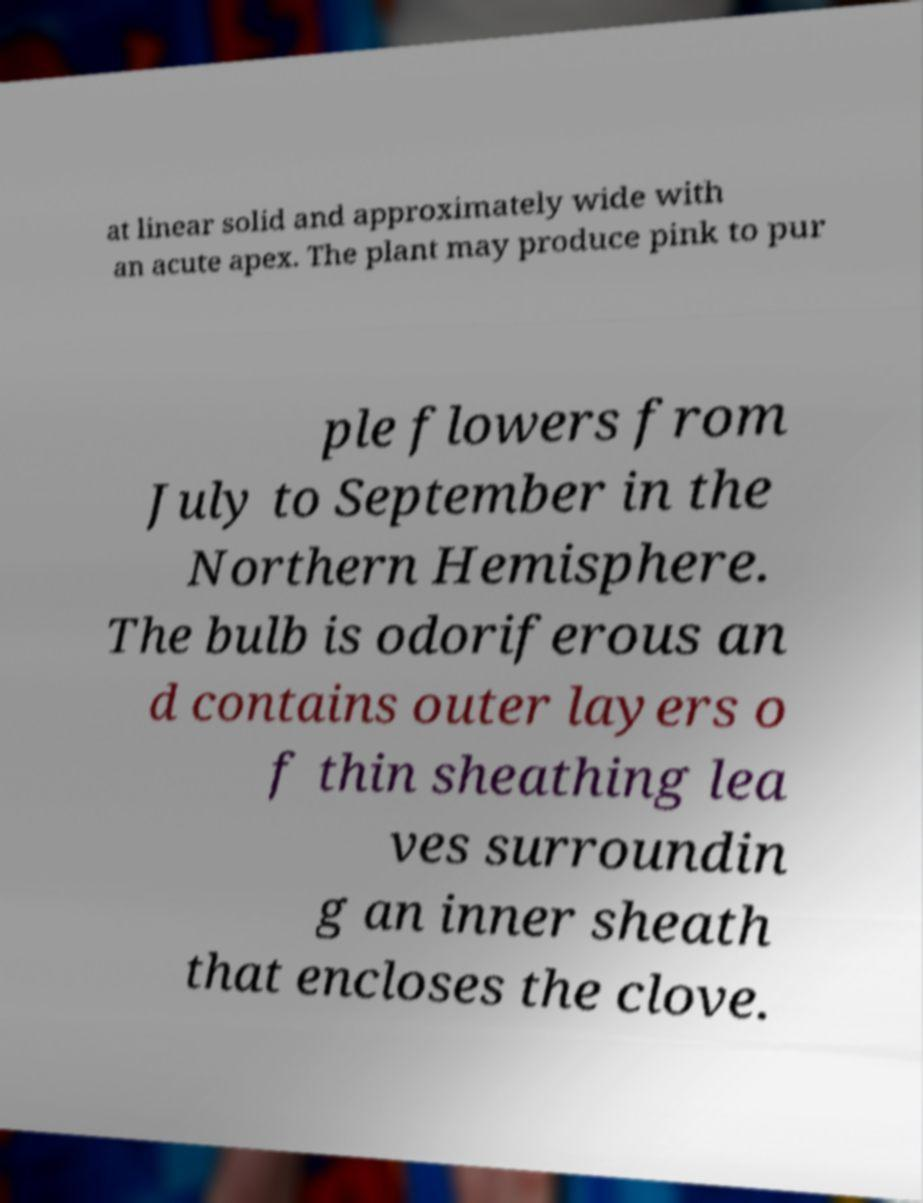There's text embedded in this image that I need extracted. Can you transcribe it verbatim? at linear solid and approximately wide with an acute apex. The plant may produce pink to pur ple flowers from July to September in the Northern Hemisphere. The bulb is odoriferous an d contains outer layers o f thin sheathing lea ves surroundin g an inner sheath that encloses the clove. 